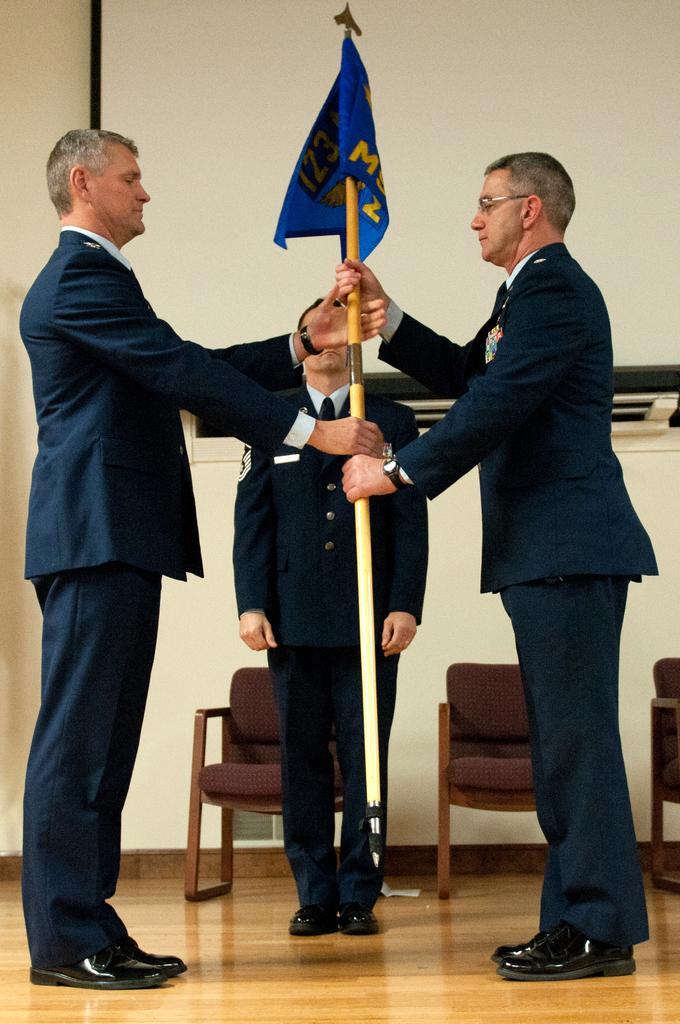Can you describe this image briefly? In this picture there are three persons who are wearing the suit, trouser and shoe. Two of them are holding a blue flag. In the back there are three chairs near to the projector screen. On the left there is a wall. 